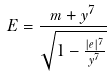<formula> <loc_0><loc_0><loc_500><loc_500>E = \frac { m + y ^ { 7 } } { \sqrt { 1 - \frac { | e | ^ { 7 } } { y ^ { 7 } } } }</formula> 